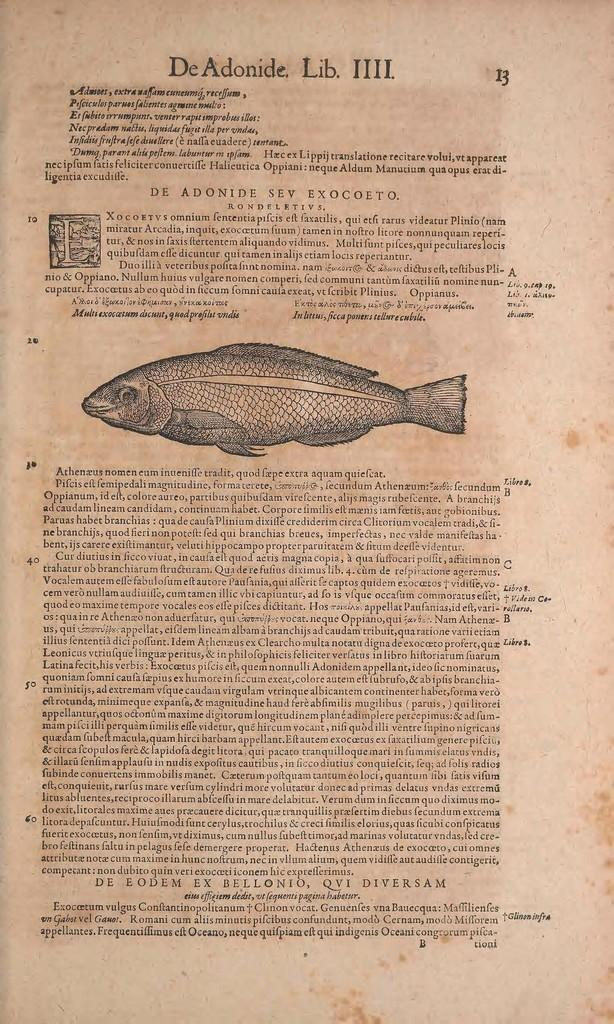What is present on the paper in the image? There are words, numbers, and an image of a fish on the paper. Can you describe the content of the paper? The paper contains words, numbers, and an image of a fish. What type of image is depicted on the paper? There is an image of a fish on the paper. What type of lunch is being served in the image? There is no lunch present in the image; it only features a paper with words, numbers, and an image of a fish. Who is the partner mentioned in the image? There is no mention of a partner in the image; it only features a paper with words, numbers, and an image of a fish. 